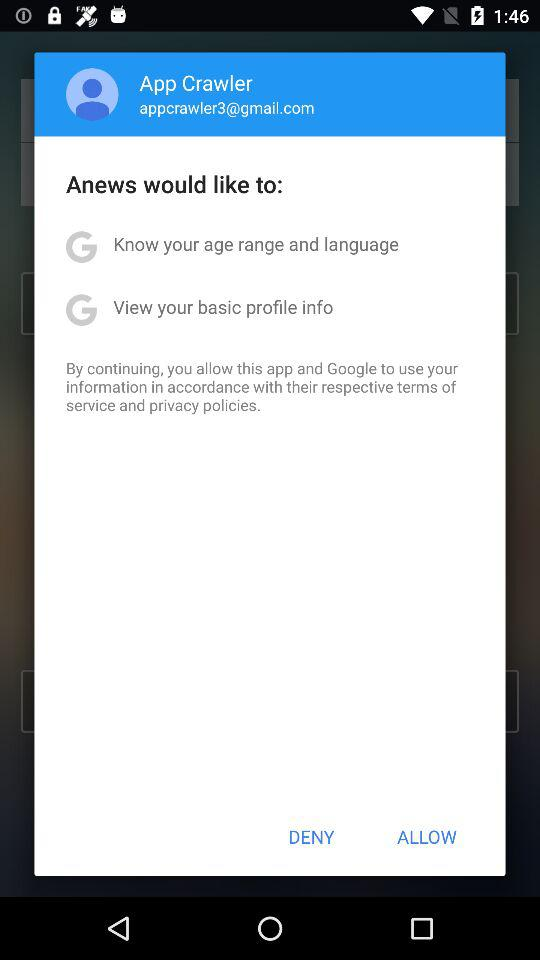What application would like to know my age range and language? The application "Anews" would like to know your age range and language. 